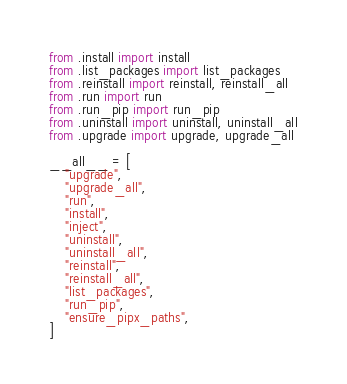<code> <loc_0><loc_0><loc_500><loc_500><_Python_>from .install import install
from .list_packages import list_packages
from .reinstall import reinstall, reinstall_all
from .run import run
from .run_pip import run_pip
from .uninstall import uninstall, uninstall_all
from .upgrade import upgrade, upgrade_all

__all__ = [
    "upgrade",
    "upgrade_all",
    "run",
    "install",
    "inject",
    "uninstall",
    "uninstall_all",
    "reinstall",
    "reinstall_all",
    "list_packages",
    "run_pip",
    "ensure_pipx_paths",
]
</code> 